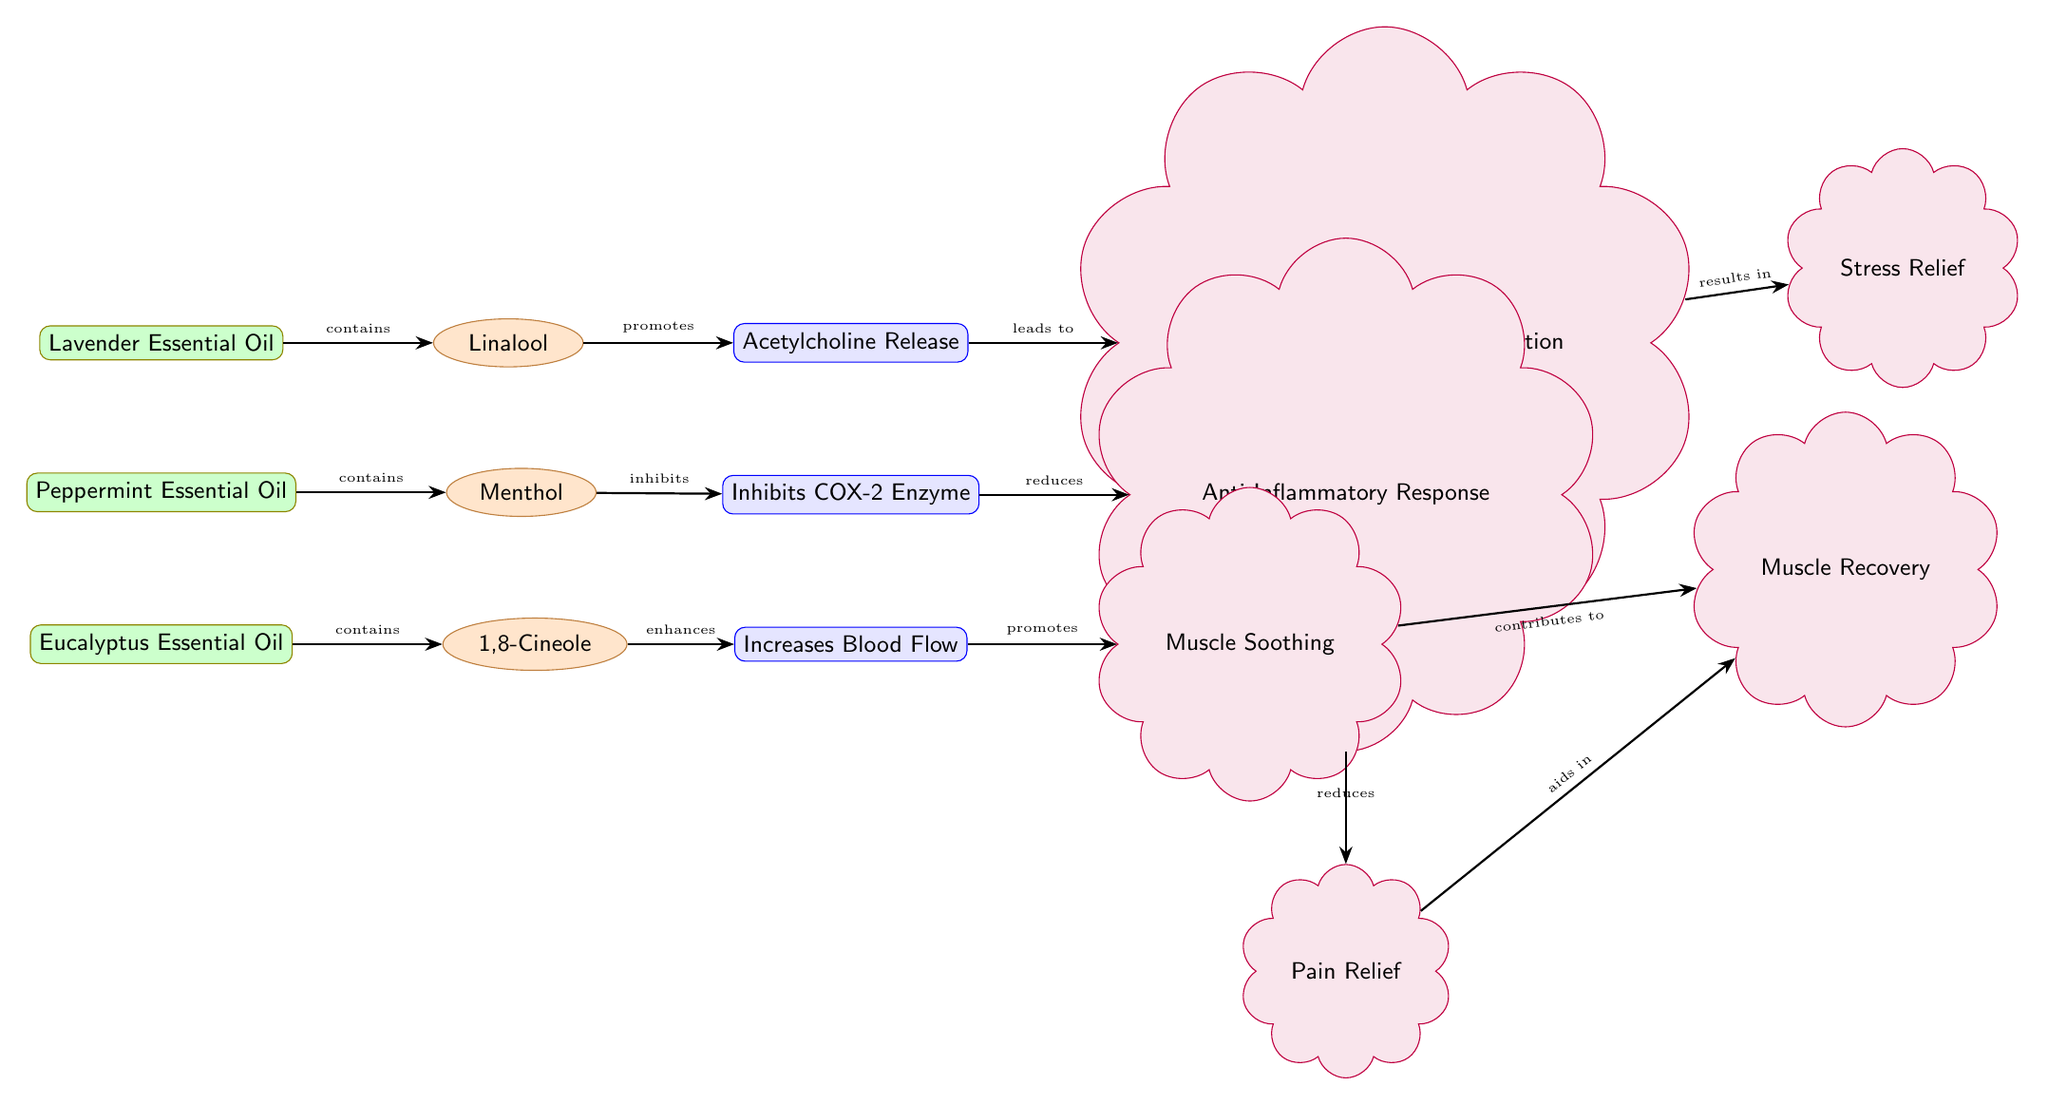What oils are represented in the diagram? The diagram lists three essential oils: Lavender Essential Oil, Peppermint Essential Oil, and Eucalyptus Essential Oil. These are all shown at the top of the diagram.
Answer: Lavender Essential Oil, Peppermint Essential Oil, Eucalyptus Essential Oil How many compounds are linked to the essential oils? Each of the three essential oils is linked to one compound, resulting in a total of three compounds (Linalool, Menthol, and Cineole). They are positioned directly to the right of each essential oil.
Answer: 3 What process is initiated by Linalool? According to the diagram, Linalool promotes the release of Acetylcholine. This is indicated by the arrow from Linalool to the Acetylcholine Release process.
Answer: Acetylcholine Release Which effect is connected to the Inhibition of COX-2? The diagram indicates that the Inhibition of COX-2 process reduces the Anti-Inflammatory Response effect, as shown by the arrow pointing from Inhibits COX-2 to Anti-Inflammatory.
Answer: Anti-Inflammatory Response What is the final effect that results from Central Nervous System Relaxation? The diagram illustrates that Central Nervous System Relaxation leads to Stress Relief. This connection is depicted with an arrow directing from CNS Relaxation to Stress Relief.
Answer: Stress Relief Which essential oil enhances Blood Flow Increase? The diagram shows that Eucalyptus Essential Oil, through its component Cineole, enhances Blood Flow Increase, as indicated by the arrow pointing from Cineole to Blood Flow Increase.
Answer: Eucalyptus Essential Oil What contributes to Muscle Recovery according to the diagram? The diagram specifies that both Muscle Soothing and Pain Relief contribute to Muscle Recovery, with arrows leading into the Muscle Recovery effect from both of these processes.
Answer: Muscle Soothing, Pain Relief What is the relationship between Menthol and Pain Relief? The diagram does not show a direct relationship between Menthol and Pain Relief. Menthol inhibits the COX-2 enzyme, which reduces inflammation and can lead to Pain Relief, but they are connected indirectly.
Answer: Indirect (no direct link) 